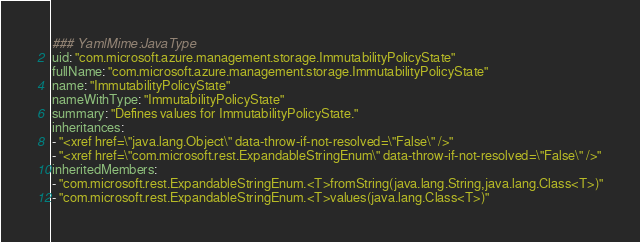Convert code to text. <code><loc_0><loc_0><loc_500><loc_500><_YAML_>### YamlMime:JavaType
uid: "com.microsoft.azure.management.storage.ImmutabilityPolicyState"
fullName: "com.microsoft.azure.management.storage.ImmutabilityPolicyState"
name: "ImmutabilityPolicyState"
nameWithType: "ImmutabilityPolicyState"
summary: "Defines values for ImmutabilityPolicyState."
inheritances:
- "<xref href=\"java.lang.Object\" data-throw-if-not-resolved=\"False\" />"
- "<xref href=\"com.microsoft.rest.ExpandableStringEnum\" data-throw-if-not-resolved=\"False\" />"
inheritedMembers:
- "com.microsoft.rest.ExpandableStringEnum.<T>fromString(java.lang.String,java.lang.Class<T>)"
- "com.microsoft.rest.ExpandableStringEnum.<T>values(java.lang.Class<T>)"</code> 